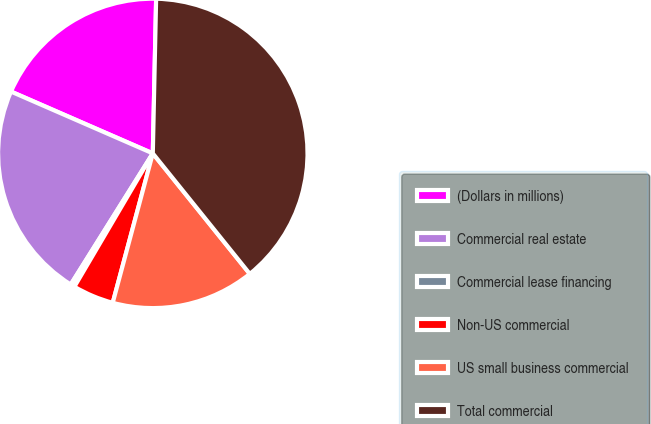Convert chart. <chart><loc_0><loc_0><loc_500><loc_500><pie_chart><fcel>(Dollars in millions)<fcel>Commercial real estate<fcel>Commercial lease financing<fcel>Non-US commercial<fcel>US small business commercial<fcel>Total commercial<nl><fcel>18.8%<fcel>22.64%<fcel>0.44%<fcel>4.29%<fcel>14.96%<fcel>38.87%<nl></chart> 